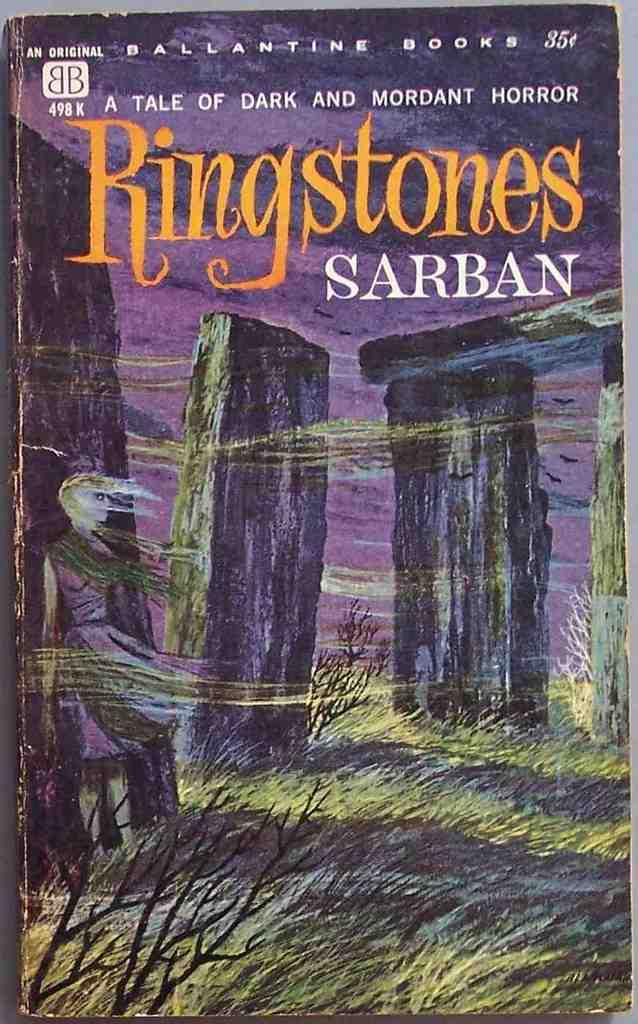<image>
Give a short and clear explanation of the subsequent image. Book cover that says the word Ringstones in yellow. 